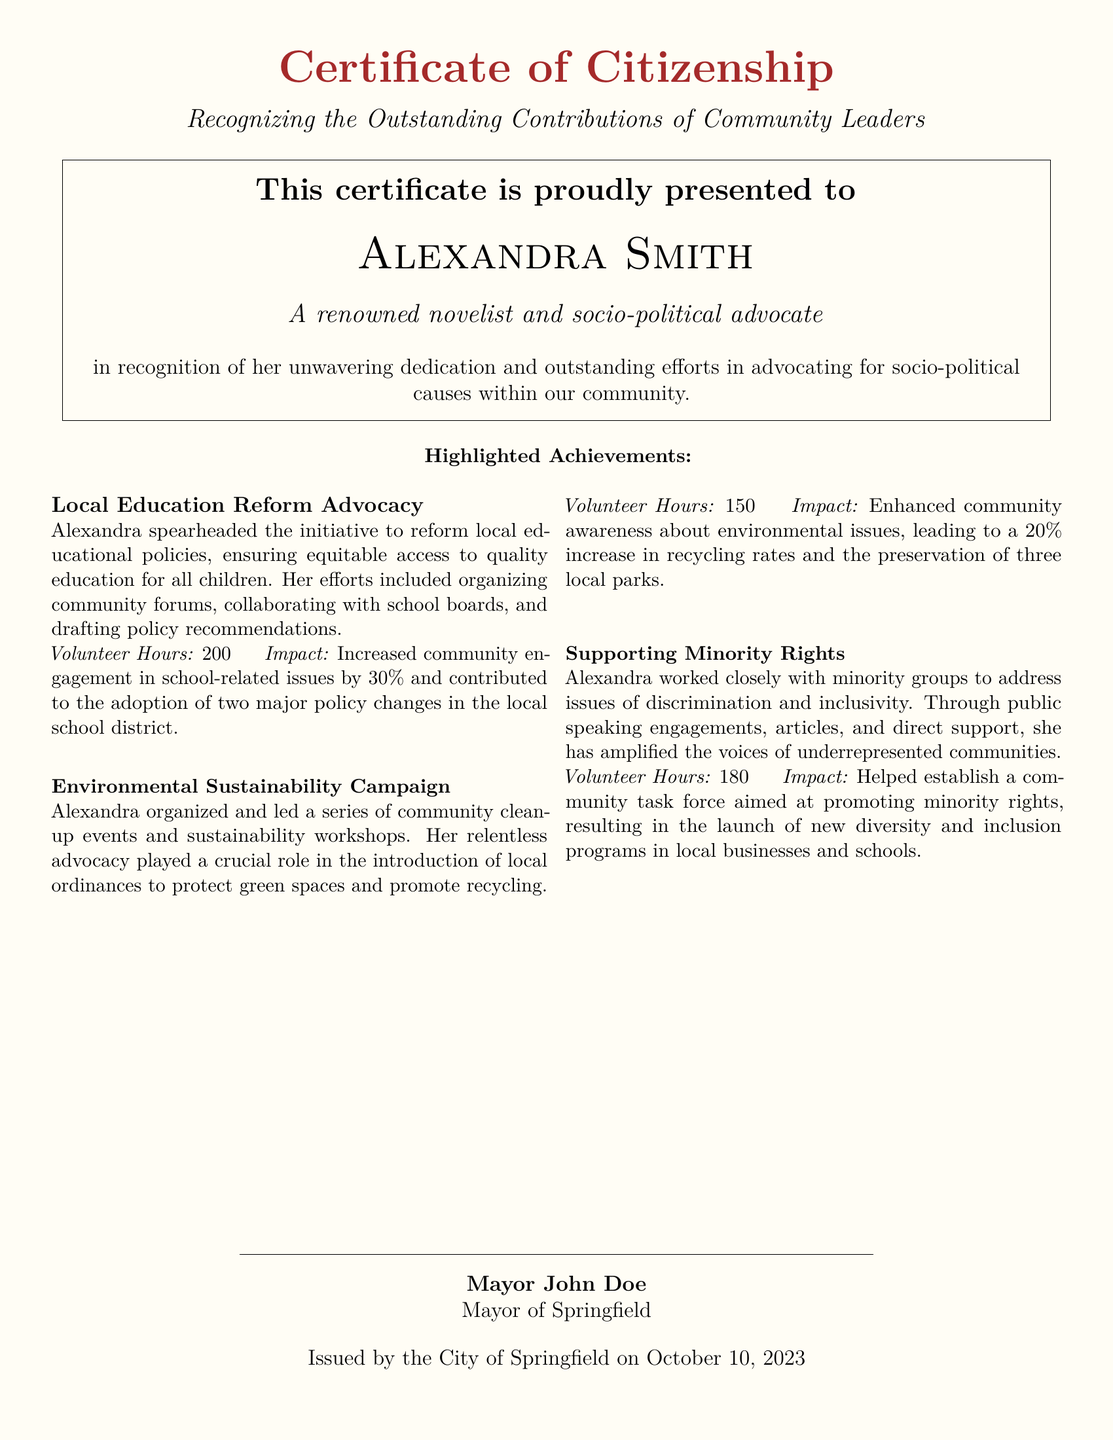What is the name of the recipient? The name of the recipient is presented in the certificate, which is Alexandra Smith.
Answer: Alexandra Smith What title is given to Alexandra Smith? The document states that Alexandra Smith is recognized as a "renowned novelist and socio-political advocate."
Answer: renowned novelist and socio-political advocate How many volunteer hours did Alexandra contribute to local education reform advocacy? The document specifies the volunteer hours dedicated to this specific achievement as 200.
Answer: 200 What impact did Alexandra's environmental sustainability campaign have on recycling rates? The document indicates that her efforts led to a 20% increase in recycling rates within the community.
Answer: 20% Who issued the certificate? The name of the person who issued the certificate is specified as Mayor John Doe.
Answer: Mayor John Doe On what date was the certificate issued? The date of issue is mentioned in the document as October 10, 2023.
Answer: October 10, 2023 What was the impact of Alexandra's efforts on community engagement in school-related issues? The document states that community engagement in school-related issues increased by 30%.
Answer: 30% Which community issues did Alexandra work on regarding minority rights? The document implies her work focused on discrimination and inclusivity for minority groups.
Answer: discrimination and inclusivity What was the main objective of the community task force established by Alexandra? The document indicates that the task force aimed at promoting minority rights.
Answer: promoting minority rights 